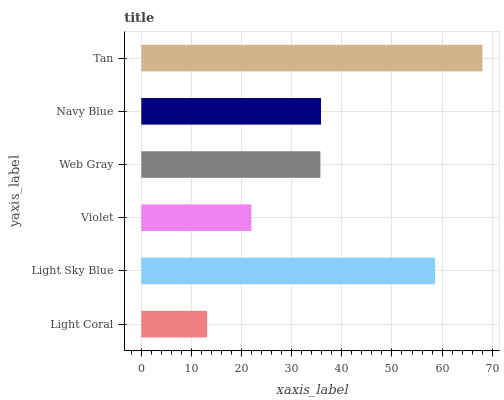Is Light Coral the minimum?
Answer yes or no. Yes. Is Tan the maximum?
Answer yes or no. Yes. Is Light Sky Blue the minimum?
Answer yes or no. No. Is Light Sky Blue the maximum?
Answer yes or no. No. Is Light Sky Blue greater than Light Coral?
Answer yes or no. Yes. Is Light Coral less than Light Sky Blue?
Answer yes or no. Yes. Is Light Coral greater than Light Sky Blue?
Answer yes or no. No. Is Light Sky Blue less than Light Coral?
Answer yes or no. No. Is Navy Blue the high median?
Answer yes or no. Yes. Is Web Gray the low median?
Answer yes or no. Yes. Is Violet the high median?
Answer yes or no. No. Is Light Coral the low median?
Answer yes or no. No. 